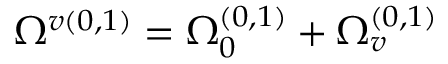<formula> <loc_0><loc_0><loc_500><loc_500>\Omega ^ { v ( 0 , 1 ) } = \Omega _ { 0 } ^ { ( 0 , 1 ) } + \Omega _ { v } ^ { ( 0 , 1 ) }</formula> 